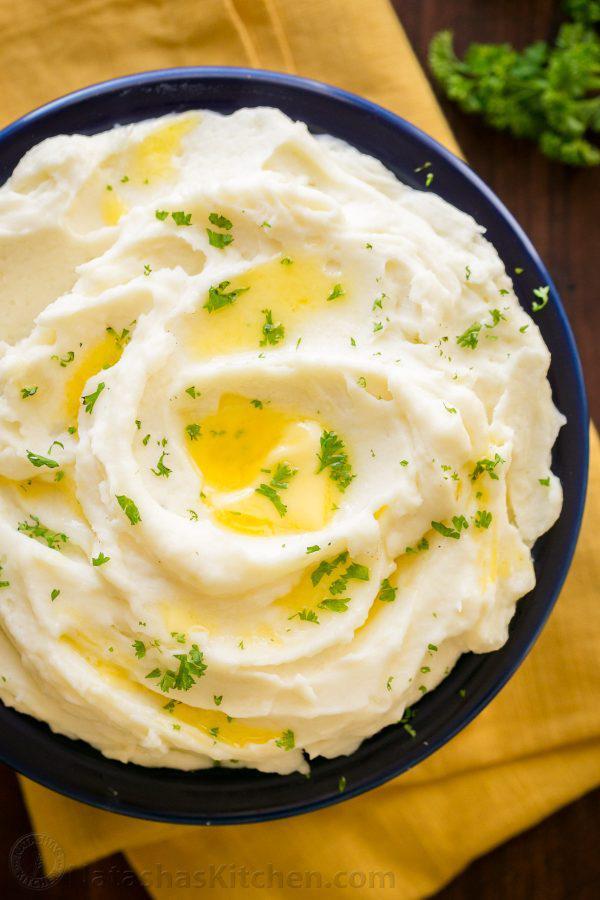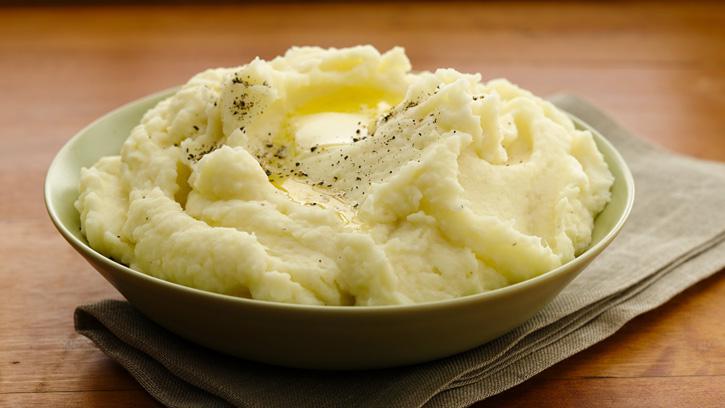The first image is the image on the left, the second image is the image on the right. For the images shown, is this caption "The right hand dish has slightly fluted edges." true? Answer yes or no. No. 